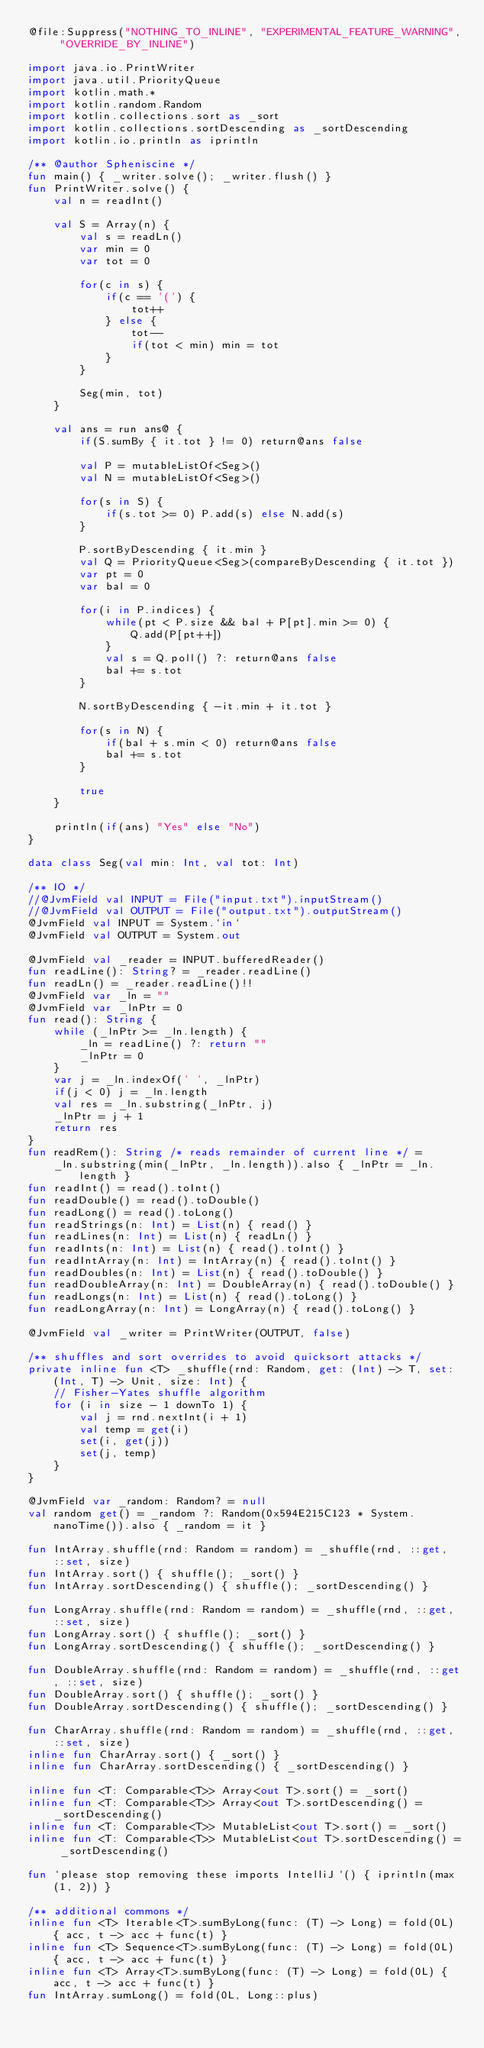Convert code to text. <code><loc_0><loc_0><loc_500><loc_500><_Kotlin_>@file:Suppress("NOTHING_TO_INLINE", "EXPERIMENTAL_FEATURE_WARNING", "OVERRIDE_BY_INLINE")

import java.io.PrintWriter
import java.util.PriorityQueue
import kotlin.math.*
import kotlin.random.Random
import kotlin.collections.sort as _sort
import kotlin.collections.sortDescending as _sortDescending
import kotlin.io.println as iprintln

/** @author Spheniscine */
fun main() { _writer.solve(); _writer.flush() }
fun PrintWriter.solve() {
    val n = readInt()

    val S = Array(n) {
        val s = readLn()
        var min = 0
        var tot = 0

        for(c in s) {
            if(c == '(') {
                tot++
            } else {
                tot--
                if(tot < min) min = tot
            }
        }

        Seg(min, tot)
    }

    val ans = run ans@ {
        if(S.sumBy { it.tot } != 0) return@ans false

        val P = mutableListOf<Seg>()
        val N = mutableListOf<Seg>()

        for(s in S) {
            if(s.tot >= 0) P.add(s) else N.add(s)
        }

        P.sortByDescending { it.min }
        val Q = PriorityQueue<Seg>(compareByDescending { it.tot })
        var pt = 0
        var bal = 0

        for(i in P.indices) {
            while(pt < P.size && bal + P[pt].min >= 0) {
                Q.add(P[pt++])
            }
            val s = Q.poll() ?: return@ans false
            bal += s.tot
        }

        N.sortByDescending { -it.min + it.tot }

        for(s in N) {
            if(bal + s.min < 0) return@ans false
            bal += s.tot
        }

        true
    }

    println(if(ans) "Yes" else "No")
}

data class Seg(val min: Int, val tot: Int)

/** IO */
//@JvmField val INPUT = File("input.txt").inputStream()
//@JvmField val OUTPUT = File("output.txt").outputStream()
@JvmField val INPUT = System.`in`
@JvmField val OUTPUT = System.out

@JvmField val _reader = INPUT.bufferedReader()
fun readLine(): String? = _reader.readLine()
fun readLn() = _reader.readLine()!!
@JvmField var _ln = ""
@JvmField var _lnPtr = 0
fun read(): String {
    while (_lnPtr >= _ln.length) {
        _ln = readLine() ?: return ""
        _lnPtr = 0
    }
    var j = _ln.indexOf(' ', _lnPtr)
    if(j < 0) j = _ln.length
    val res = _ln.substring(_lnPtr, j)
    _lnPtr = j + 1
    return res
}
fun readRem(): String /* reads remainder of current line */ =
    _ln.substring(min(_lnPtr, _ln.length)).also { _lnPtr = _ln.length }
fun readInt() = read().toInt()
fun readDouble() = read().toDouble()
fun readLong() = read().toLong()
fun readStrings(n: Int) = List(n) { read() }
fun readLines(n: Int) = List(n) { readLn() }
fun readInts(n: Int) = List(n) { read().toInt() }
fun readIntArray(n: Int) = IntArray(n) { read().toInt() }
fun readDoubles(n: Int) = List(n) { read().toDouble() }
fun readDoubleArray(n: Int) = DoubleArray(n) { read().toDouble() }
fun readLongs(n: Int) = List(n) { read().toLong() }
fun readLongArray(n: Int) = LongArray(n) { read().toLong() }

@JvmField val _writer = PrintWriter(OUTPUT, false)

/** shuffles and sort overrides to avoid quicksort attacks */
private inline fun <T> _shuffle(rnd: Random, get: (Int) -> T, set: (Int, T) -> Unit, size: Int) {
    // Fisher-Yates shuffle algorithm
    for (i in size - 1 downTo 1) {
        val j = rnd.nextInt(i + 1)
        val temp = get(i)
        set(i, get(j))
        set(j, temp)
    }
}

@JvmField var _random: Random? = null
val random get() = _random ?: Random(0x594E215C123 * System.nanoTime()).also { _random = it }

fun IntArray.shuffle(rnd: Random = random) = _shuffle(rnd, ::get, ::set, size)
fun IntArray.sort() { shuffle(); _sort() }
fun IntArray.sortDescending() { shuffle(); _sortDescending() }

fun LongArray.shuffle(rnd: Random = random) = _shuffle(rnd, ::get, ::set, size)
fun LongArray.sort() { shuffle(); _sort() }
fun LongArray.sortDescending() { shuffle(); _sortDescending() }

fun DoubleArray.shuffle(rnd: Random = random) = _shuffle(rnd, ::get, ::set, size)
fun DoubleArray.sort() { shuffle(); _sort() }
fun DoubleArray.sortDescending() { shuffle(); _sortDescending() }

fun CharArray.shuffle(rnd: Random = random) = _shuffle(rnd, ::get, ::set, size)
inline fun CharArray.sort() { _sort() }
inline fun CharArray.sortDescending() { _sortDescending() }

inline fun <T: Comparable<T>> Array<out T>.sort() = _sort()
inline fun <T: Comparable<T>> Array<out T>.sortDescending() = _sortDescending()
inline fun <T: Comparable<T>> MutableList<out T>.sort() = _sort()
inline fun <T: Comparable<T>> MutableList<out T>.sortDescending() = _sortDescending()

fun `please stop removing these imports IntelliJ`() { iprintln(max(1, 2)) }

/** additional commons */
inline fun <T> Iterable<T>.sumByLong(func: (T) -> Long) = fold(0L) { acc, t -> acc + func(t) }
inline fun <T> Sequence<T>.sumByLong(func: (T) -> Long) = fold(0L) { acc, t -> acc + func(t) }
inline fun <T> Array<T>.sumByLong(func: (T) -> Long) = fold(0L) { acc, t -> acc + func(t) }
fun IntArray.sumLong() = fold(0L, Long::plus)
</code> 